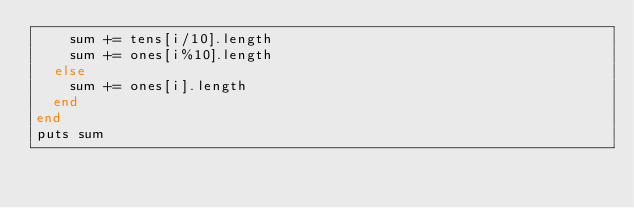<code> <loc_0><loc_0><loc_500><loc_500><_Ruby_>    sum += tens[i/10].length
    sum += ones[i%10].length
  else
    sum += ones[i].length
  end
end
puts sum
</code> 